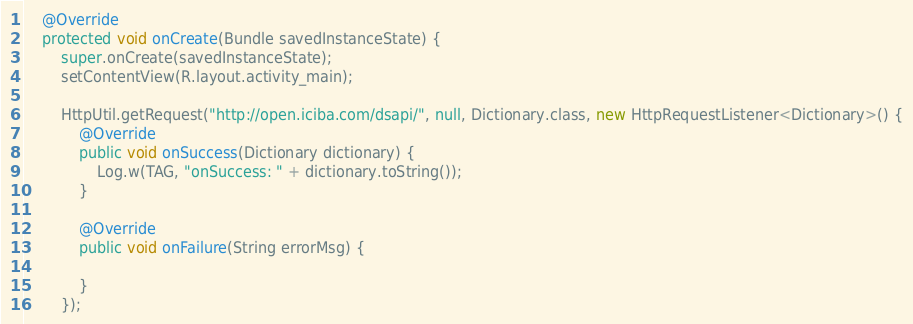<code> <loc_0><loc_0><loc_500><loc_500><_Java_>

    @Override
    protected void onCreate(Bundle savedInstanceState) {
        super.onCreate(savedInstanceState);
        setContentView(R.layout.activity_main);

        HttpUtil.getRequest("http://open.iciba.com/dsapi/", null, Dictionary.class, new HttpRequestListener<Dictionary>() {
            @Override
            public void onSuccess(Dictionary dictionary) {
                Log.w(TAG, "onSuccess: " + dictionary.toString());
            }

            @Override
            public void onFailure(String errorMsg) {

            }
        });
</code> 